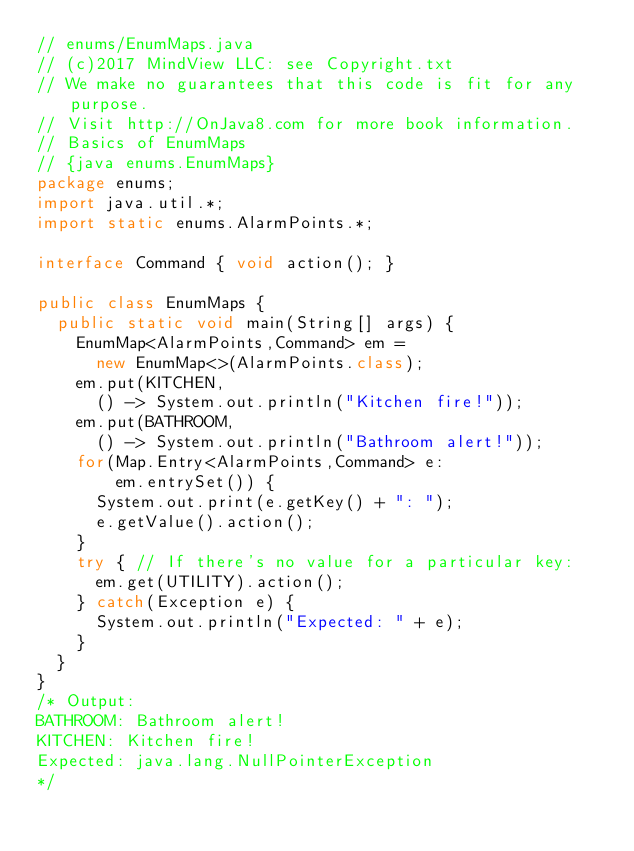<code> <loc_0><loc_0><loc_500><loc_500><_Java_>// enums/EnumMaps.java
// (c)2017 MindView LLC: see Copyright.txt
// We make no guarantees that this code is fit for any purpose.
// Visit http://OnJava8.com for more book information.
// Basics of EnumMaps
// {java enums.EnumMaps}
package enums;
import java.util.*;
import static enums.AlarmPoints.*;

interface Command { void action(); }

public class EnumMaps {
  public static void main(String[] args) {
    EnumMap<AlarmPoints,Command> em =
      new EnumMap<>(AlarmPoints.class);
    em.put(KITCHEN,
      () -> System.out.println("Kitchen fire!"));
    em.put(BATHROOM,
      () -> System.out.println("Bathroom alert!"));
    for(Map.Entry<AlarmPoints,Command> e:
        em.entrySet()) {
      System.out.print(e.getKey() + ": ");
      e.getValue().action();
    }
    try { // If there's no value for a particular key:
      em.get(UTILITY).action();
    } catch(Exception e) {
      System.out.println("Expected: " + e);
    }
  }
}
/* Output:
BATHROOM: Bathroom alert!
KITCHEN: Kitchen fire!
Expected: java.lang.NullPointerException
*/
</code> 